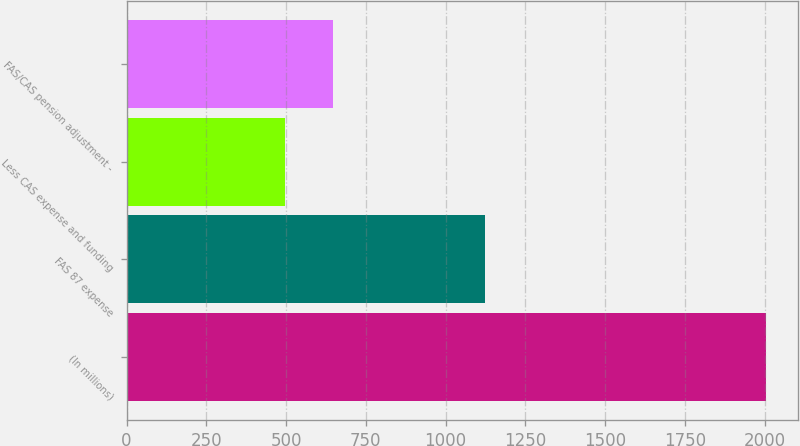<chart> <loc_0><loc_0><loc_500><loc_500><bar_chart><fcel>(In millions)<fcel>FAS 87 expense<fcel>Less CAS expense and funding<fcel>FAS/CAS pension adjustment -<nl><fcel>2005<fcel>1124<fcel>498<fcel>648.7<nl></chart> 